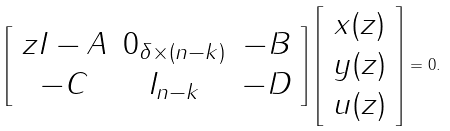<formula> <loc_0><loc_0><loc_500><loc_500>\left [ \begin{array} { c c c } z I - A & 0 _ { \delta \times ( n - k ) } & - B \\ - C & I _ { n - k } & - D \end{array} \right ] \left [ \begin{array} { c } x ( z ) \\ y ( z ) \\ u ( z ) \end{array} \right ] = 0 .</formula> 